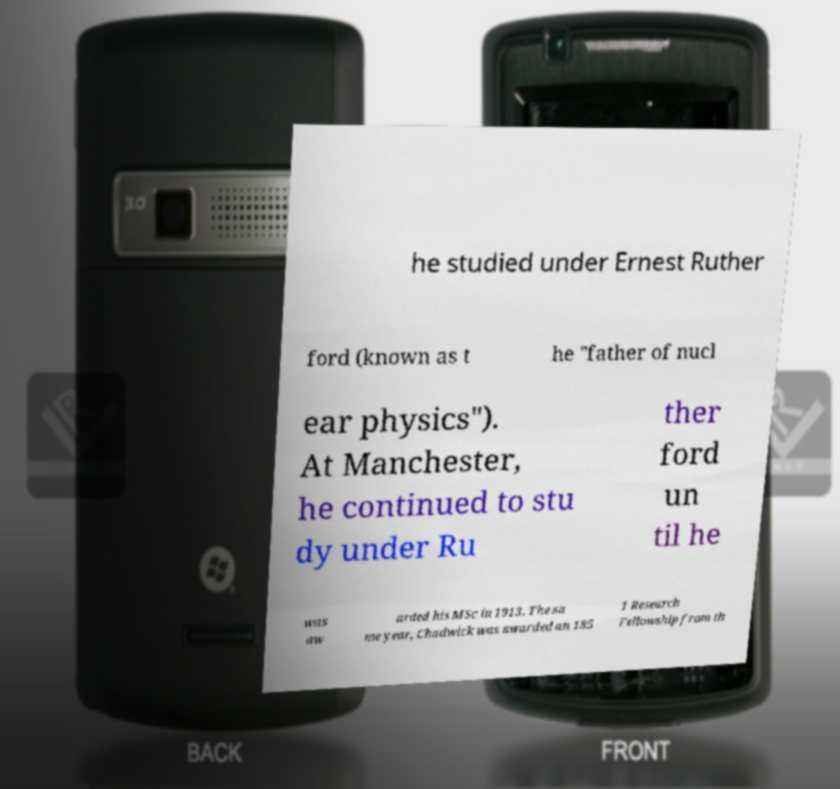I need the written content from this picture converted into text. Can you do that? he studied under Ernest Ruther ford (known as t he "father of nucl ear physics"). At Manchester, he continued to stu dy under Ru ther ford un til he was aw arded his MSc in 1913. The sa me year, Chadwick was awarded an 185 1 Research Fellowship from th 